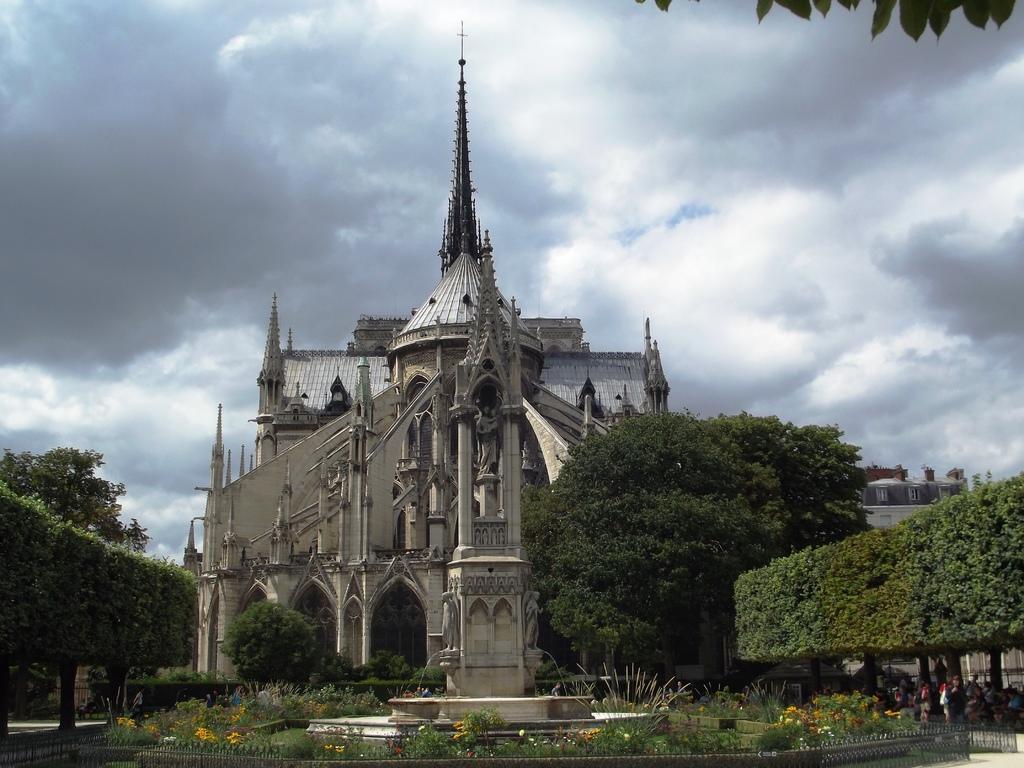Can you describe this image briefly? In the picture i can see some plants, trees on left and right side of the picture and in the background of the picture there is a building and top of the picture there is cloudy sky 